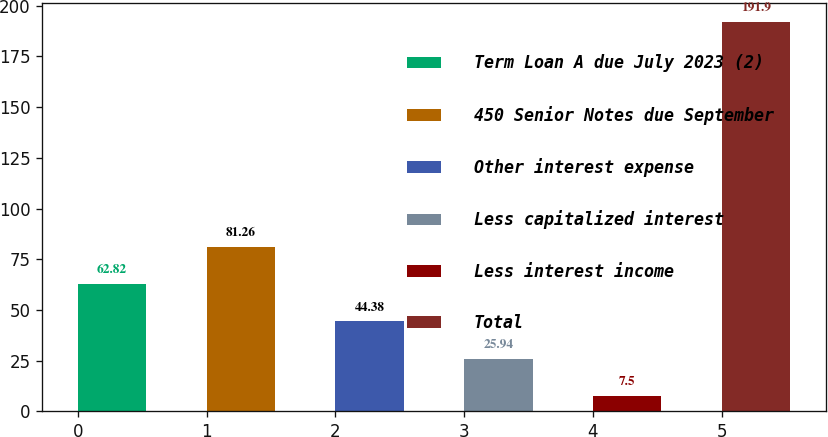<chart> <loc_0><loc_0><loc_500><loc_500><bar_chart><fcel>Term Loan A due July 2023 (2)<fcel>450 Senior Notes due September<fcel>Other interest expense<fcel>Less capitalized interest<fcel>Less interest income<fcel>Total<nl><fcel>62.82<fcel>81.26<fcel>44.38<fcel>25.94<fcel>7.5<fcel>191.9<nl></chart> 